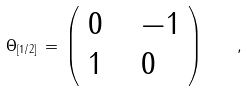<formula> <loc_0><loc_0><loc_500><loc_500>\Theta _ { [ 1 / 2 ] } \, = \, \left ( \begin{array} { l l l } { 0 } & { \, } & { - 1 } \\ { 1 } & { \, } & { 0 } \end{array} \right ) \quad ,</formula> 